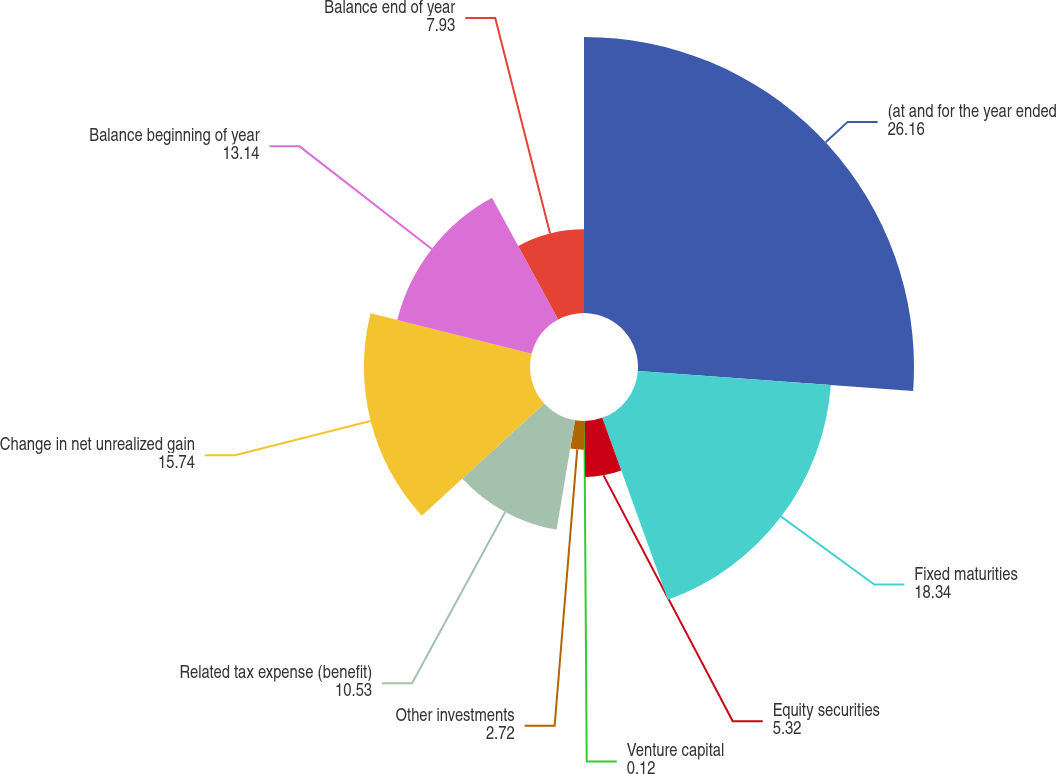Convert chart. <chart><loc_0><loc_0><loc_500><loc_500><pie_chart><fcel>(at and for the year ended<fcel>Fixed maturities<fcel>Equity securities<fcel>Venture capital<fcel>Other investments<fcel>Related tax expense (benefit)<fcel>Change in net unrealized gain<fcel>Balance beginning of year<fcel>Balance end of year<nl><fcel>26.16%<fcel>18.34%<fcel>5.32%<fcel>0.12%<fcel>2.72%<fcel>10.53%<fcel>15.74%<fcel>13.14%<fcel>7.93%<nl></chart> 